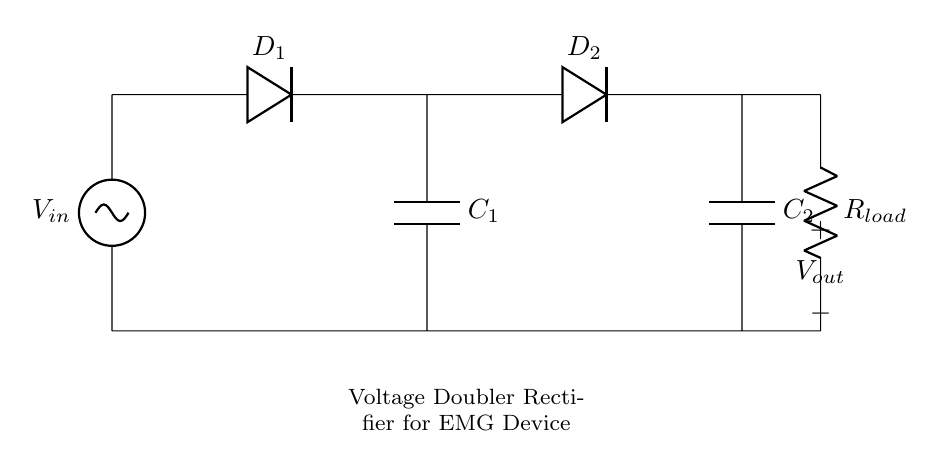What is the input voltage of the circuit? The input voltage is indicated as V_in, which is connected at the left side of the circuit.
Answer: V_in What are the types of diodes used in this circuit? The circuit contains two diodes labeled as D_1 and D_2, which are standard components in a rectifier circuit.
Answer: D_1 and D_2 How many capacitors are there in the circuit? There are two capacitors labeled as C_1 and C_2, connected at different points in the circuit to smooth the output voltage.
Answer: 2 What is the purpose of the load resistor in this circuit? The load resistor, labeled as R_load, is connected to the output of the rectifier to provide a load for testing or utilizing the voltage doubler output.
Answer: To provide a load Why is this circuit designed as a voltage doubler? This circuit is designed as a voltage doubler because it uses two diodes and two capacitors to effectively double the output voltage compared to the input voltage by charging both capacitors in sequence to the input waveform.
Answer: To double the voltage What is the output voltage connection in the circuit? The output voltage, labeled as V_out, is taken from the node after the load resistor (R_load), indicating where the voltage can be measured or used.
Answer: V_out 